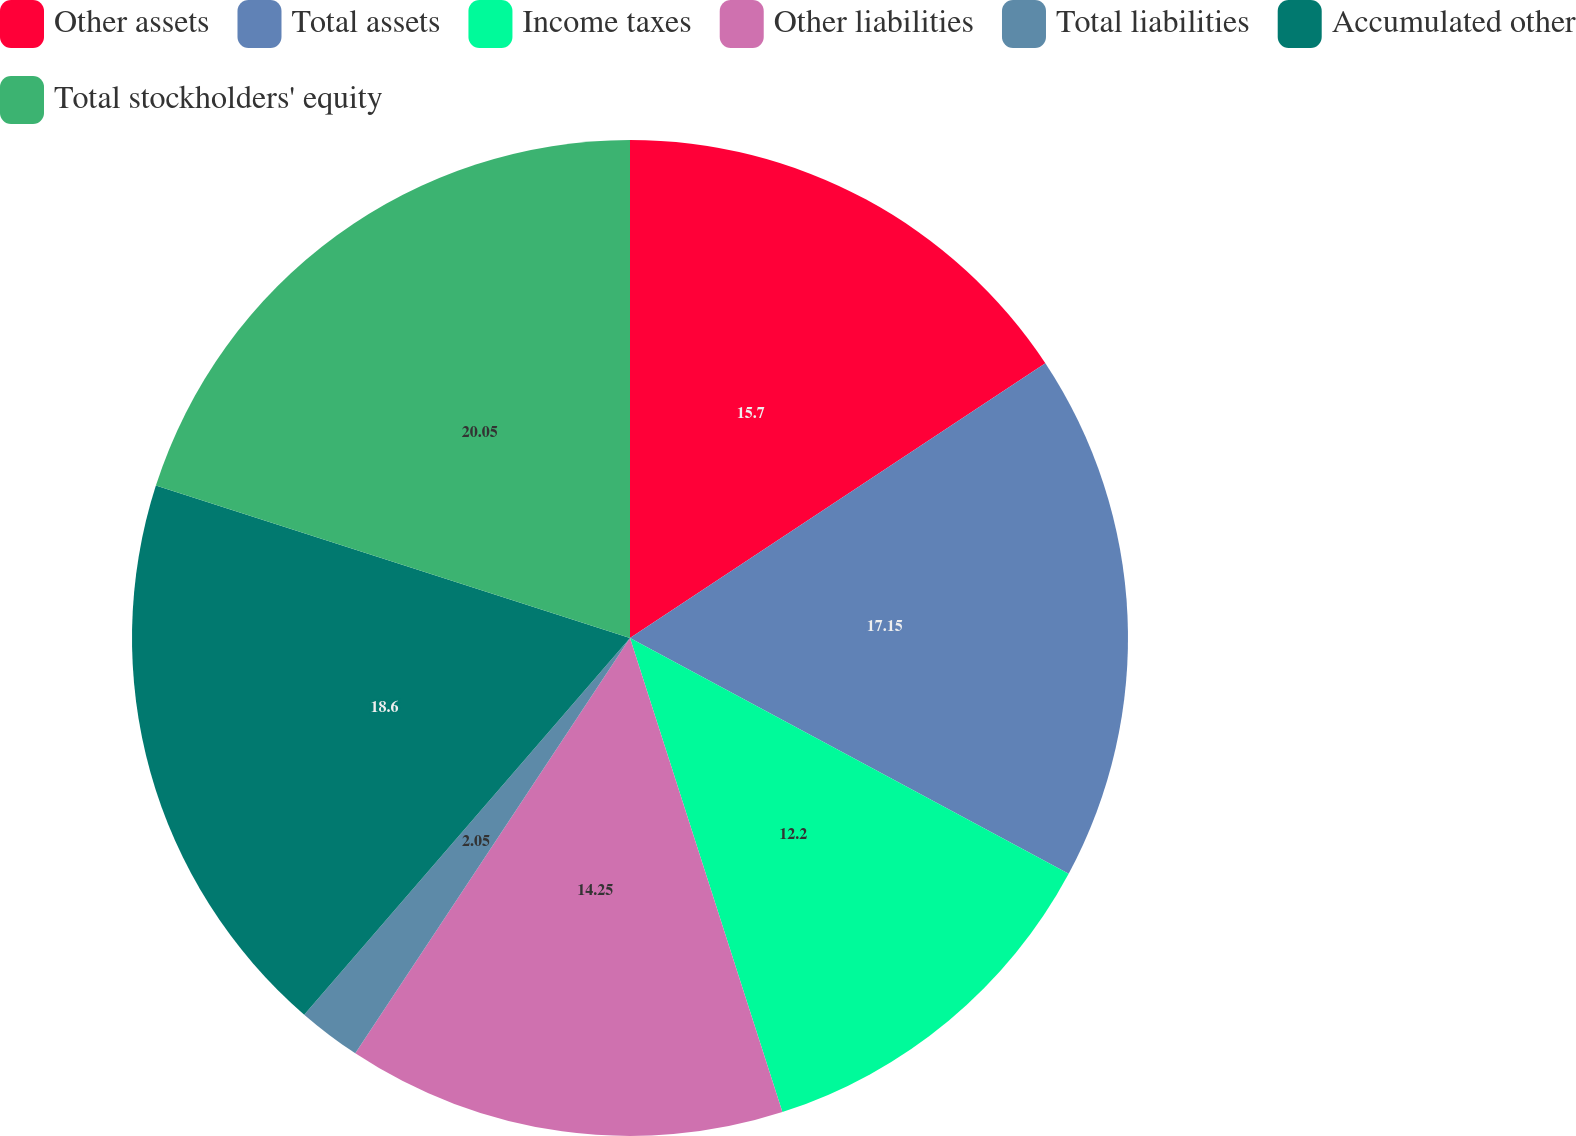<chart> <loc_0><loc_0><loc_500><loc_500><pie_chart><fcel>Other assets<fcel>Total assets<fcel>Income taxes<fcel>Other liabilities<fcel>Total liabilities<fcel>Accumulated other<fcel>Total stockholders' equity<nl><fcel>15.7%<fcel>17.15%<fcel>12.2%<fcel>14.25%<fcel>2.05%<fcel>18.6%<fcel>20.05%<nl></chart> 